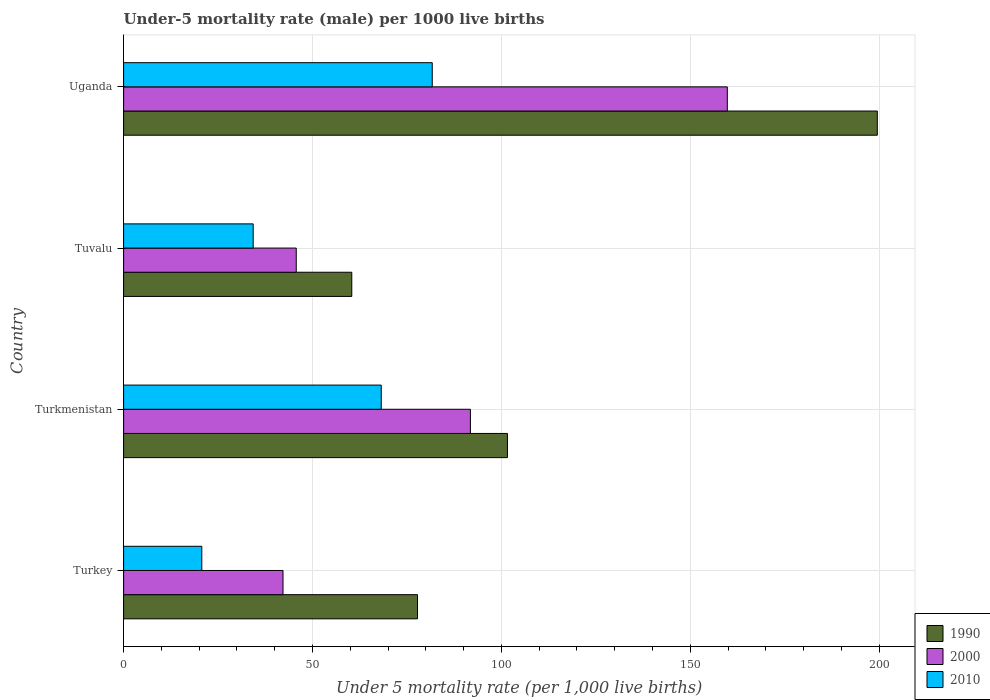How many different coloured bars are there?
Your answer should be compact. 3. Are the number of bars per tick equal to the number of legend labels?
Provide a succinct answer. Yes. Are the number of bars on each tick of the Y-axis equal?
Ensure brevity in your answer.  Yes. What is the label of the 1st group of bars from the top?
Offer a terse response. Uganda. In how many cases, is the number of bars for a given country not equal to the number of legend labels?
Your answer should be compact. 0. What is the under-five mortality rate in 2010 in Turkmenistan?
Give a very brief answer. 68.2. Across all countries, what is the maximum under-five mortality rate in 2000?
Offer a terse response. 159.8. Across all countries, what is the minimum under-five mortality rate in 2000?
Offer a very short reply. 42.2. In which country was the under-five mortality rate in 2010 maximum?
Make the answer very short. Uganda. In which country was the under-five mortality rate in 2010 minimum?
Give a very brief answer. Turkey. What is the total under-five mortality rate in 1990 in the graph?
Keep it short and to the point. 439.3. What is the difference between the under-five mortality rate in 1990 in Uganda and the under-five mortality rate in 2010 in Tuvalu?
Offer a very short reply. 165.2. What is the average under-five mortality rate in 1990 per country?
Provide a succinct answer. 109.82. What is the difference between the under-five mortality rate in 2010 and under-five mortality rate in 1990 in Uganda?
Offer a very short reply. -117.8. What is the ratio of the under-five mortality rate in 1990 in Turkey to that in Turkmenistan?
Make the answer very short. 0.77. What is the difference between the highest and the second highest under-five mortality rate in 1990?
Offer a terse response. 97.9. What is the difference between the highest and the lowest under-five mortality rate in 2000?
Keep it short and to the point. 117.6. In how many countries, is the under-five mortality rate in 1990 greater than the average under-five mortality rate in 1990 taken over all countries?
Provide a short and direct response. 1. Is the sum of the under-five mortality rate in 1990 in Turkey and Uganda greater than the maximum under-five mortality rate in 2010 across all countries?
Make the answer very short. Yes. What does the 3rd bar from the top in Tuvalu represents?
Make the answer very short. 1990. Is it the case that in every country, the sum of the under-five mortality rate in 2010 and under-five mortality rate in 2000 is greater than the under-five mortality rate in 1990?
Give a very brief answer. No. Are all the bars in the graph horizontal?
Provide a succinct answer. Yes. What is the difference between two consecutive major ticks on the X-axis?
Keep it short and to the point. 50. Does the graph contain any zero values?
Keep it short and to the point. No. Does the graph contain grids?
Your answer should be very brief. Yes. How many legend labels are there?
Offer a terse response. 3. What is the title of the graph?
Your answer should be very brief. Under-5 mortality rate (male) per 1000 live births. Does "1980" appear as one of the legend labels in the graph?
Keep it short and to the point. No. What is the label or title of the X-axis?
Give a very brief answer. Under 5 mortality rate (per 1,0 live births). What is the label or title of the Y-axis?
Make the answer very short. Country. What is the Under 5 mortality rate (per 1,000 live births) in 1990 in Turkey?
Offer a terse response. 77.8. What is the Under 5 mortality rate (per 1,000 live births) of 2000 in Turkey?
Provide a short and direct response. 42.2. What is the Under 5 mortality rate (per 1,000 live births) in 2010 in Turkey?
Provide a short and direct response. 20.7. What is the Under 5 mortality rate (per 1,000 live births) of 1990 in Turkmenistan?
Offer a terse response. 101.6. What is the Under 5 mortality rate (per 1,000 live births) in 2000 in Turkmenistan?
Provide a succinct answer. 91.8. What is the Under 5 mortality rate (per 1,000 live births) in 2010 in Turkmenistan?
Give a very brief answer. 68.2. What is the Under 5 mortality rate (per 1,000 live births) in 1990 in Tuvalu?
Ensure brevity in your answer.  60.4. What is the Under 5 mortality rate (per 1,000 live births) in 2000 in Tuvalu?
Keep it short and to the point. 45.7. What is the Under 5 mortality rate (per 1,000 live births) of 2010 in Tuvalu?
Your answer should be compact. 34.3. What is the Under 5 mortality rate (per 1,000 live births) of 1990 in Uganda?
Keep it short and to the point. 199.5. What is the Under 5 mortality rate (per 1,000 live births) of 2000 in Uganda?
Make the answer very short. 159.8. What is the Under 5 mortality rate (per 1,000 live births) in 2010 in Uganda?
Ensure brevity in your answer.  81.7. Across all countries, what is the maximum Under 5 mortality rate (per 1,000 live births) in 1990?
Provide a short and direct response. 199.5. Across all countries, what is the maximum Under 5 mortality rate (per 1,000 live births) of 2000?
Make the answer very short. 159.8. Across all countries, what is the maximum Under 5 mortality rate (per 1,000 live births) of 2010?
Make the answer very short. 81.7. Across all countries, what is the minimum Under 5 mortality rate (per 1,000 live births) in 1990?
Provide a succinct answer. 60.4. Across all countries, what is the minimum Under 5 mortality rate (per 1,000 live births) of 2000?
Your response must be concise. 42.2. Across all countries, what is the minimum Under 5 mortality rate (per 1,000 live births) in 2010?
Give a very brief answer. 20.7. What is the total Under 5 mortality rate (per 1,000 live births) of 1990 in the graph?
Your answer should be compact. 439.3. What is the total Under 5 mortality rate (per 1,000 live births) of 2000 in the graph?
Make the answer very short. 339.5. What is the total Under 5 mortality rate (per 1,000 live births) of 2010 in the graph?
Give a very brief answer. 204.9. What is the difference between the Under 5 mortality rate (per 1,000 live births) of 1990 in Turkey and that in Turkmenistan?
Your answer should be compact. -23.8. What is the difference between the Under 5 mortality rate (per 1,000 live births) in 2000 in Turkey and that in Turkmenistan?
Provide a succinct answer. -49.6. What is the difference between the Under 5 mortality rate (per 1,000 live births) of 2010 in Turkey and that in Turkmenistan?
Make the answer very short. -47.5. What is the difference between the Under 5 mortality rate (per 1,000 live births) in 2000 in Turkey and that in Tuvalu?
Your answer should be compact. -3.5. What is the difference between the Under 5 mortality rate (per 1,000 live births) in 1990 in Turkey and that in Uganda?
Offer a very short reply. -121.7. What is the difference between the Under 5 mortality rate (per 1,000 live births) in 2000 in Turkey and that in Uganda?
Provide a succinct answer. -117.6. What is the difference between the Under 5 mortality rate (per 1,000 live births) of 2010 in Turkey and that in Uganda?
Your answer should be very brief. -61. What is the difference between the Under 5 mortality rate (per 1,000 live births) in 1990 in Turkmenistan and that in Tuvalu?
Provide a succinct answer. 41.2. What is the difference between the Under 5 mortality rate (per 1,000 live births) of 2000 in Turkmenistan and that in Tuvalu?
Your answer should be very brief. 46.1. What is the difference between the Under 5 mortality rate (per 1,000 live births) in 2010 in Turkmenistan and that in Tuvalu?
Offer a very short reply. 33.9. What is the difference between the Under 5 mortality rate (per 1,000 live births) in 1990 in Turkmenistan and that in Uganda?
Make the answer very short. -97.9. What is the difference between the Under 5 mortality rate (per 1,000 live births) in 2000 in Turkmenistan and that in Uganda?
Offer a very short reply. -68. What is the difference between the Under 5 mortality rate (per 1,000 live births) in 2010 in Turkmenistan and that in Uganda?
Your answer should be very brief. -13.5. What is the difference between the Under 5 mortality rate (per 1,000 live births) in 1990 in Tuvalu and that in Uganda?
Offer a very short reply. -139.1. What is the difference between the Under 5 mortality rate (per 1,000 live births) of 2000 in Tuvalu and that in Uganda?
Give a very brief answer. -114.1. What is the difference between the Under 5 mortality rate (per 1,000 live births) in 2010 in Tuvalu and that in Uganda?
Your answer should be compact. -47.4. What is the difference between the Under 5 mortality rate (per 1,000 live births) in 1990 in Turkey and the Under 5 mortality rate (per 1,000 live births) in 2000 in Turkmenistan?
Ensure brevity in your answer.  -14. What is the difference between the Under 5 mortality rate (per 1,000 live births) of 1990 in Turkey and the Under 5 mortality rate (per 1,000 live births) of 2010 in Turkmenistan?
Your response must be concise. 9.6. What is the difference between the Under 5 mortality rate (per 1,000 live births) in 2000 in Turkey and the Under 5 mortality rate (per 1,000 live births) in 2010 in Turkmenistan?
Your answer should be compact. -26. What is the difference between the Under 5 mortality rate (per 1,000 live births) in 1990 in Turkey and the Under 5 mortality rate (per 1,000 live births) in 2000 in Tuvalu?
Keep it short and to the point. 32.1. What is the difference between the Under 5 mortality rate (per 1,000 live births) in 1990 in Turkey and the Under 5 mortality rate (per 1,000 live births) in 2010 in Tuvalu?
Offer a terse response. 43.5. What is the difference between the Under 5 mortality rate (per 1,000 live births) of 2000 in Turkey and the Under 5 mortality rate (per 1,000 live births) of 2010 in Tuvalu?
Provide a short and direct response. 7.9. What is the difference between the Under 5 mortality rate (per 1,000 live births) in 1990 in Turkey and the Under 5 mortality rate (per 1,000 live births) in 2000 in Uganda?
Offer a very short reply. -82. What is the difference between the Under 5 mortality rate (per 1,000 live births) in 2000 in Turkey and the Under 5 mortality rate (per 1,000 live births) in 2010 in Uganda?
Keep it short and to the point. -39.5. What is the difference between the Under 5 mortality rate (per 1,000 live births) of 1990 in Turkmenistan and the Under 5 mortality rate (per 1,000 live births) of 2000 in Tuvalu?
Keep it short and to the point. 55.9. What is the difference between the Under 5 mortality rate (per 1,000 live births) in 1990 in Turkmenistan and the Under 5 mortality rate (per 1,000 live births) in 2010 in Tuvalu?
Your response must be concise. 67.3. What is the difference between the Under 5 mortality rate (per 1,000 live births) of 2000 in Turkmenistan and the Under 5 mortality rate (per 1,000 live births) of 2010 in Tuvalu?
Your answer should be compact. 57.5. What is the difference between the Under 5 mortality rate (per 1,000 live births) of 1990 in Turkmenistan and the Under 5 mortality rate (per 1,000 live births) of 2000 in Uganda?
Your answer should be compact. -58.2. What is the difference between the Under 5 mortality rate (per 1,000 live births) of 1990 in Turkmenistan and the Under 5 mortality rate (per 1,000 live births) of 2010 in Uganda?
Make the answer very short. 19.9. What is the difference between the Under 5 mortality rate (per 1,000 live births) of 2000 in Turkmenistan and the Under 5 mortality rate (per 1,000 live births) of 2010 in Uganda?
Provide a short and direct response. 10.1. What is the difference between the Under 5 mortality rate (per 1,000 live births) in 1990 in Tuvalu and the Under 5 mortality rate (per 1,000 live births) in 2000 in Uganda?
Give a very brief answer. -99.4. What is the difference between the Under 5 mortality rate (per 1,000 live births) in 1990 in Tuvalu and the Under 5 mortality rate (per 1,000 live births) in 2010 in Uganda?
Provide a short and direct response. -21.3. What is the difference between the Under 5 mortality rate (per 1,000 live births) in 2000 in Tuvalu and the Under 5 mortality rate (per 1,000 live births) in 2010 in Uganda?
Ensure brevity in your answer.  -36. What is the average Under 5 mortality rate (per 1,000 live births) in 1990 per country?
Give a very brief answer. 109.83. What is the average Under 5 mortality rate (per 1,000 live births) of 2000 per country?
Offer a terse response. 84.88. What is the average Under 5 mortality rate (per 1,000 live births) in 2010 per country?
Your answer should be very brief. 51.23. What is the difference between the Under 5 mortality rate (per 1,000 live births) in 1990 and Under 5 mortality rate (per 1,000 live births) in 2000 in Turkey?
Your response must be concise. 35.6. What is the difference between the Under 5 mortality rate (per 1,000 live births) in 1990 and Under 5 mortality rate (per 1,000 live births) in 2010 in Turkey?
Your answer should be very brief. 57.1. What is the difference between the Under 5 mortality rate (per 1,000 live births) in 2000 and Under 5 mortality rate (per 1,000 live births) in 2010 in Turkey?
Make the answer very short. 21.5. What is the difference between the Under 5 mortality rate (per 1,000 live births) of 1990 and Under 5 mortality rate (per 1,000 live births) of 2000 in Turkmenistan?
Offer a very short reply. 9.8. What is the difference between the Under 5 mortality rate (per 1,000 live births) in 1990 and Under 5 mortality rate (per 1,000 live births) in 2010 in Turkmenistan?
Provide a succinct answer. 33.4. What is the difference between the Under 5 mortality rate (per 1,000 live births) in 2000 and Under 5 mortality rate (per 1,000 live births) in 2010 in Turkmenistan?
Offer a very short reply. 23.6. What is the difference between the Under 5 mortality rate (per 1,000 live births) in 1990 and Under 5 mortality rate (per 1,000 live births) in 2010 in Tuvalu?
Keep it short and to the point. 26.1. What is the difference between the Under 5 mortality rate (per 1,000 live births) of 2000 and Under 5 mortality rate (per 1,000 live births) of 2010 in Tuvalu?
Provide a succinct answer. 11.4. What is the difference between the Under 5 mortality rate (per 1,000 live births) of 1990 and Under 5 mortality rate (per 1,000 live births) of 2000 in Uganda?
Give a very brief answer. 39.7. What is the difference between the Under 5 mortality rate (per 1,000 live births) of 1990 and Under 5 mortality rate (per 1,000 live births) of 2010 in Uganda?
Give a very brief answer. 117.8. What is the difference between the Under 5 mortality rate (per 1,000 live births) of 2000 and Under 5 mortality rate (per 1,000 live births) of 2010 in Uganda?
Offer a very short reply. 78.1. What is the ratio of the Under 5 mortality rate (per 1,000 live births) of 1990 in Turkey to that in Turkmenistan?
Provide a short and direct response. 0.77. What is the ratio of the Under 5 mortality rate (per 1,000 live births) in 2000 in Turkey to that in Turkmenistan?
Offer a terse response. 0.46. What is the ratio of the Under 5 mortality rate (per 1,000 live births) of 2010 in Turkey to that in Turkmenistan?
Give a very brief answer. 0.3. What is the ratio of the Under 5 mortality rate (per 1,000 live births) in 1990 in Turkey to that in Tuvalu?
Offer a very short reply. 1.29. What is the ratio of the Under 5 mortality rate (per 1,000 live births) of 2000 in Turkey to that in Tuvalu?
Your answer should be compact. 0.92. What is the ratio of the Under 5 mortality rate (per 1,000 live births) in 2010 in Turkey to that in Tuvalu?
Your answer should be very brief. 0.6. What is the ratio of the Under 5 mortality rate (per 1,000 live births) of 1990 in Turkey to that in Uganda?
Offer a terse response. 0.39. What is the ratio of the Under 5 mortality rate (per 1,000 live births) of 2000 in Turkey to that in Uganda?
Make the answer very short. 0.26. What is the ratio of the Under 5 mortality rate (per 1,000 live births) in 2010 in Turkey to that in Uganda?
Your answer should be compact. 0.25. What is the ratio of the Under 5 mortality rate (per 1,000 live births) in 1990 in Turkmenistan to that in Tuvalu?
Your answer should be compact. 1.68. What is the ratio of the Under 5 mortality rate (per 1,000 live births) of 2000 in Turkmenistan to that in Tuvalu?
Your answer should be compact. 2.01. What is the ratio of the Under 5 mortality rate (per 1,000 live births) of 2010 in Turkmenistan to that in Tuvalu?
Provide a short and direct response. 1.99. What is the ratio of the Under 5 mortality rate (per 1,000 live births) in 1990 in Turkmenistan to that in Uganda?
Make the answer very short. 0.51. What is the ratio of the Under 5 mortality rate (per 1,000 live births) in 2000 in Turkmenistan to that in Uganda?
Offer a very short reply. 0.57. What is the ratio of the Under 5 mortality rate (per 1,000 live births) in 2010 in Turkmenistan to that in Uganda?
Keep it short and to the point. 0.83. What is the ratio of the Under 5 mortality rate (per 1,000 live births) in 1990 in Tuvalu to that in Uganda?
Provide a succinct answer. 0.3. What is the ratio of the Under 5 mortality rate (per 1,000 live births) of 2000 in Tuvalu to that in Uganda?
Your response must be concise. 0.29. What is the ratio of the Under 5 mortality rate (per 1,000 live births) in 2010 in Tuvalu to that in Uganda?
Keep it short and to the point. 0.42. What is the difference between the highest and the second highest Under 5 mortality rate (per 1,000 live births) of 1990?
Make the answer very short. 97.9. What is the difference between the highest and the second highest Under 5 mortality rate (per 1,000 live births) of 2010?
Keep it short and to the point. 13.5. What is the difference between the highest and the lowest Under 5 mortality rate (per 1,000 live births) in 1990?
Your answer should be compact. 139.1. What is the difference between the highest and the lowest Under 5 mortality rate (per 1,000 live births) in 2000?
Make the answer very short. 117.6. What is the difference between the highest and the lowest Under 5 mortality rate (per 1,000 live births) of 2010?
Ensure brevity in your answer.  61. 